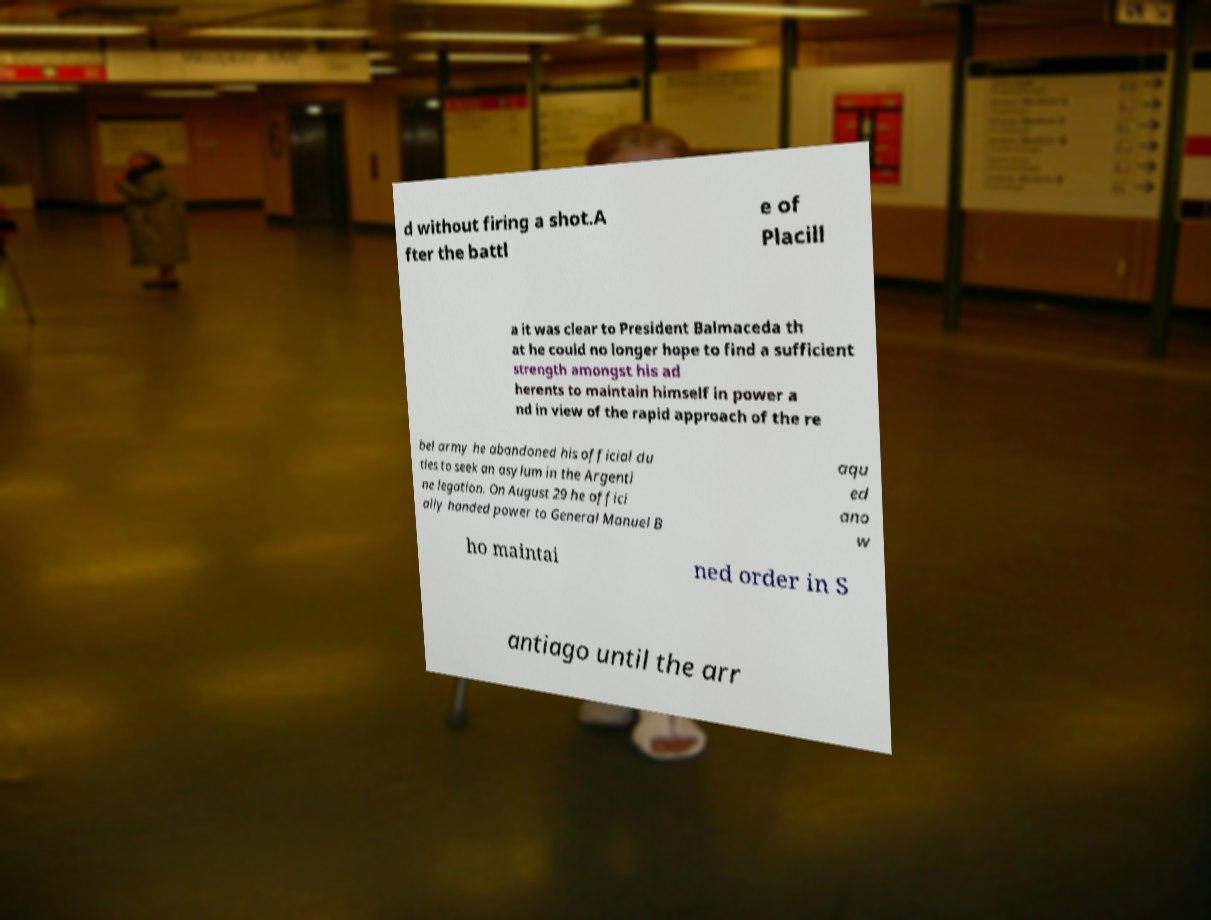Can you read and provide the text displayed in the image?This photo seems to have some interesting text. Can you extract and type it out for me? d without firing a shot.A fter the battl e of Placill a it was clear to President Balmaceda th at he could no longer hope to find a sufficient strength amongst his ad herents to maintain himself in power a nd in view of the rapid approach of the re bel army he abandoned his official du ties to seek an asylum in the Argenti ne legation. On August 29 he offici ally handed power to General Manuel B aqu ed ano w ho maintai ned order in S antiago until the arr 